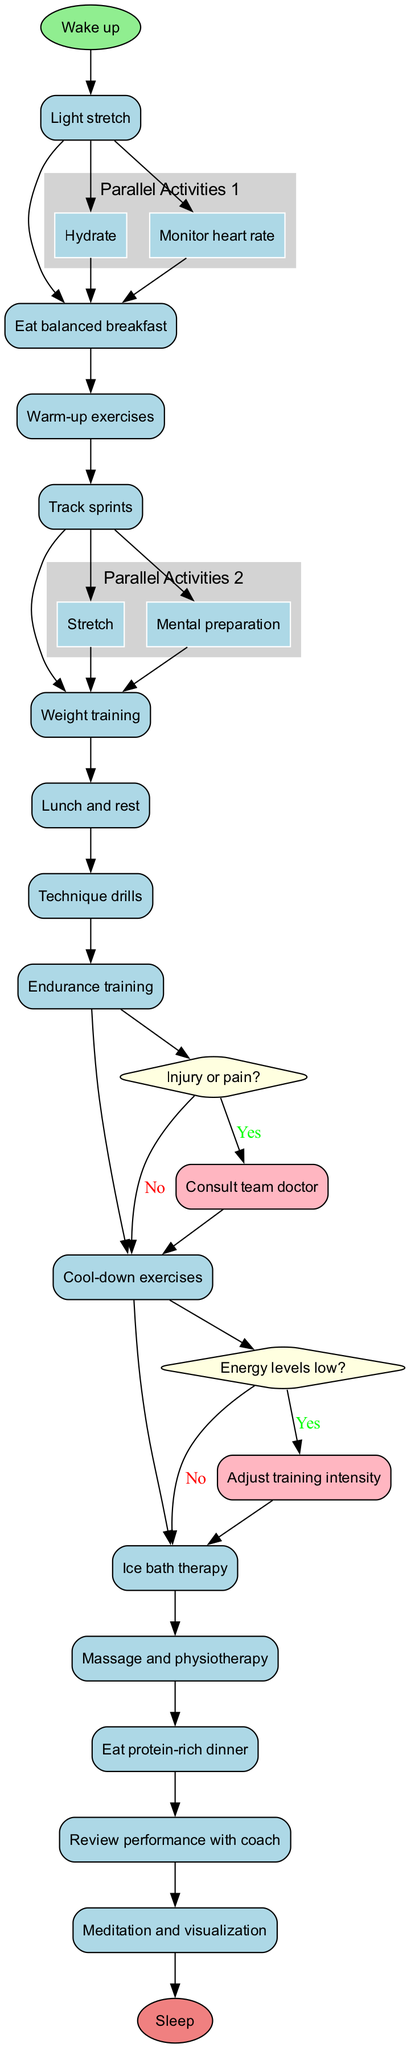What is the first activity in the routine? The first activity node in the diagram flows directly from the start node, which is labeled as "Wake up."
Answer: Wake up How many activities are in the daily training routine? By counting the nodes representing activities, there are a total of 14 distinct activities listed in the diagram.
Answer: 14 What activity follows "Track sprints"? According to the flow of the diagram, the node that directly follows "Track sprints" is labeled "Weight training."
Answer: Weight training What decision follows "Technique drills"? The decision point follows after "Technique drills" and is labeled as "Injury or pain?"
Answer: Injury or pain? If the athlete has low energy levels, what action is taken? If the condition of low energy levels is confirmed at the decision point, the route leads to the action labeled "Adjust training intensity."
Answer: Adjust training intensity How many parallel activities are identified in the diagram? The diagram includes two separate groups of parallel activities, which are highlighted in grey clusters.
Answer: 2 What is the last activity before going to sleep? The activity immediately before the end node labeled "Sleep" is "Review performance with coach."
Answer: Review performance with coach What happens if the athlete experiences injury or pain? If the condition is met for "Injury or pain?" at the decision point, the workflow indicates to "Consult team doctor."
Answer: Consult team doctor What are the two activities happening in parallel during the warm-up? The activities identified as happening in parallel before "Warm-up exercises" are "Hydrate" and "Monitor heart rate."
Answer: Hydrate, Monitor heart rate 